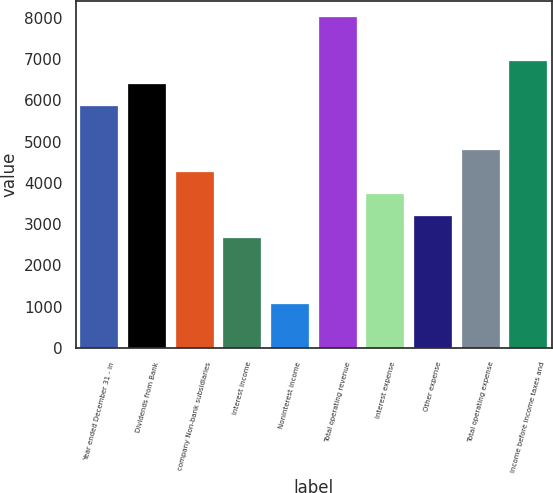<chart> <loc_0><loc_0><loc_500><loc_500><bar_chart><fcel>Year ended December 31 - in<fcel>Dividends from Bank<fcel>company Non-bank subsidiaries<fcel>Interest income<fcel>Noninterest income<fcel>Total operating revenue<fcel>Interest expense<fcel>Other expense<fcel>Total operating expense<fcel>Income before income taxes and<nl><fcel>5871.7<fcel>6405.4<fcel>4270.6<fcel>2669.5<fcel>1068.4<fcel>8006.5<fcel>3736.9<fcel>3203.2<fcel>4804.3<fcel>6939.1<nl></chart> 